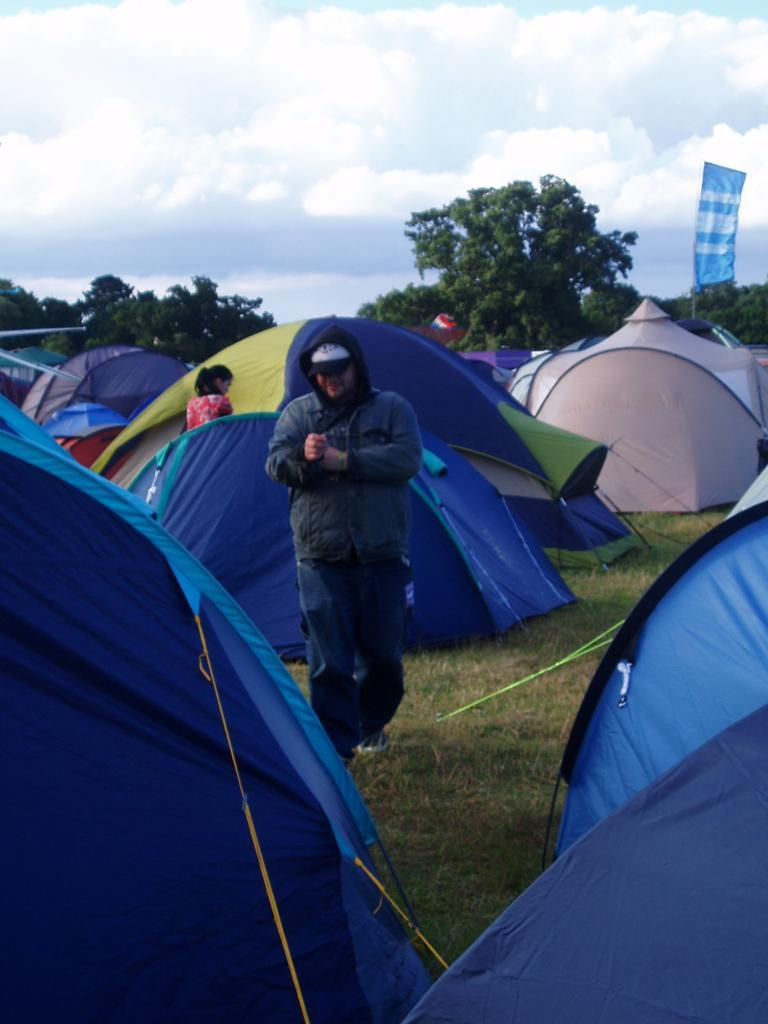What is the main subject of the image? There is a man standing in the image. What is the man's position in relation to the ground? The man is standing on the ground. What is the man wearing in the image? The man is wearing a jacket. What can be seen in the background of the image? There are many tents and trees in the background of the image. What additional object is present in the image? There is a banner in the image. How would you describe the weather based on the image? The sky is cloudy in the image. Can you tell me how many crackers the man is holding in the image? There are no crackers present in the image; the man is not holding any. What type of birth is depicted in the image? There is no birth depicted in the image; it features a man standing with a jacket on. 